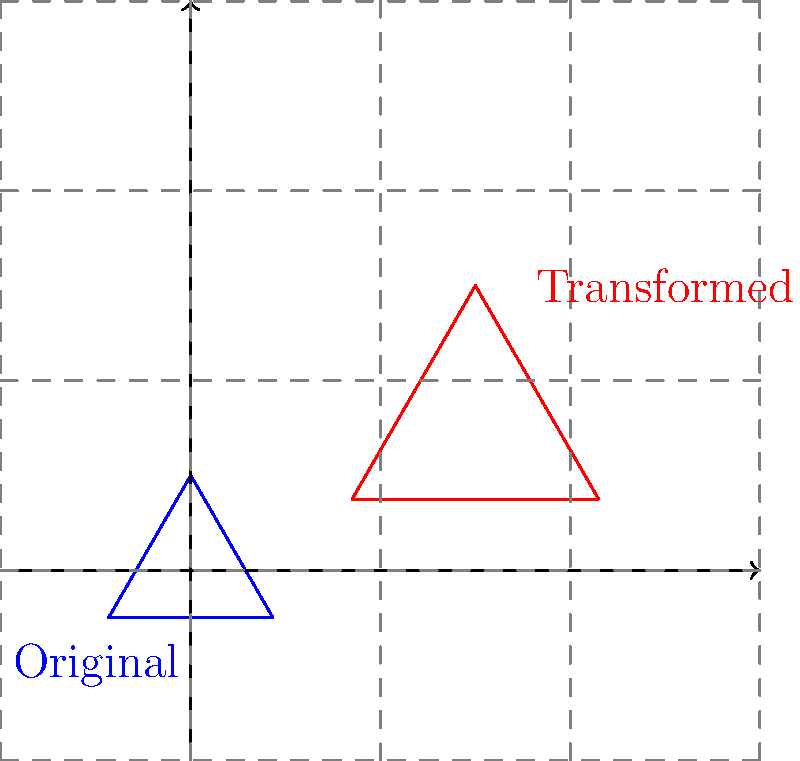A triangular cross-section of an anatomical structure is scaled by a factor of 1.5 and then translated 2 units to the right and 1 unit up. If the original triangle had an area of 4 cm², what is the area of the transformed triangle in cm²? To solve this problem, we'll follow these steps:

1) First, recall that when a shape is scaled by a factor of $k$, its area is multiplied by $k^2$.

2) In this case, the scaling factor is 1.5, so we need to calculate $(1.5)^2$:

   $(1.5)^2 = 2.25$

3) The original area of the triangle was 4 cm². To find the new area, we multiply the original area by 2.25:

   $4 \text{ cm}^2 \times 2.25 = 9 \text{ cm}^2$

4) Note that translation (moving the shape) does not affect the area, so we don't need to consider the rightward and upward movement for this calculation.

Therefore, the area of the transformed triangle is 9 cm².
Answer: 9 cm² 